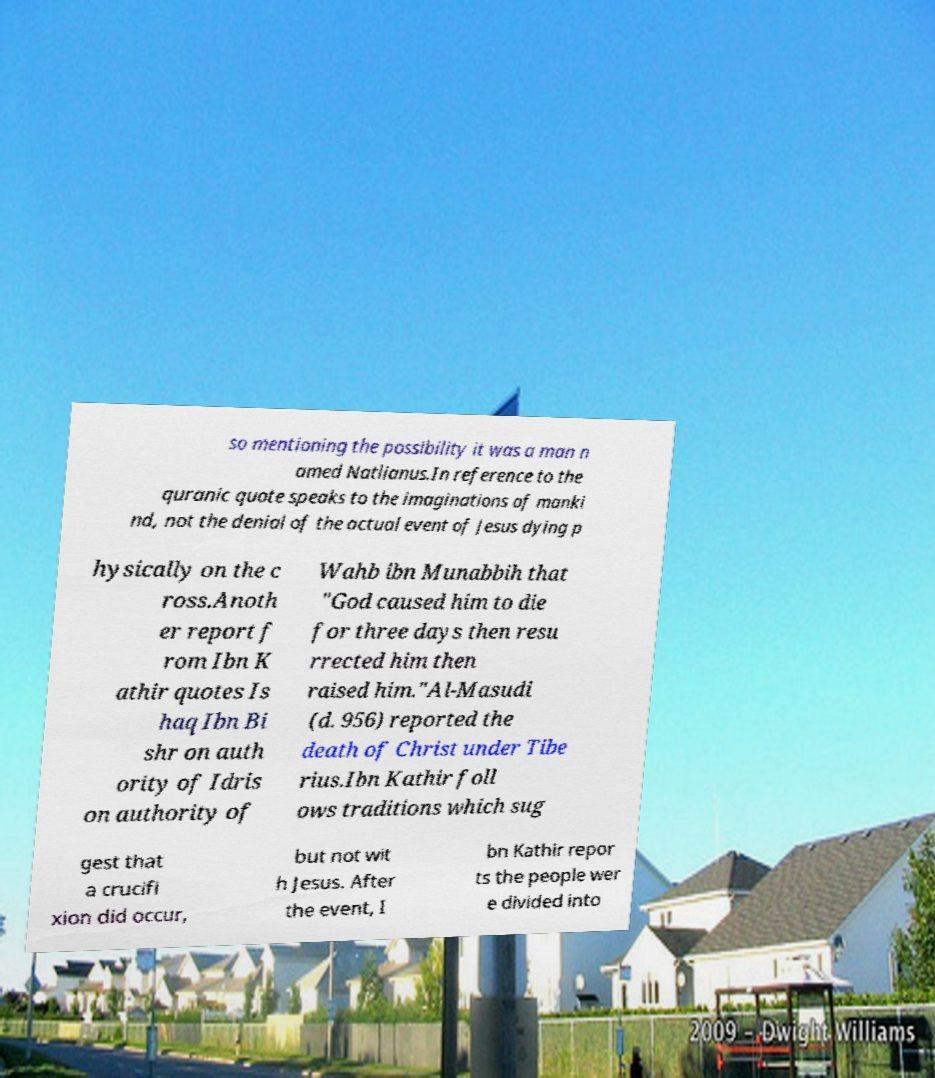Can you accurately transcribe the text from the provided image for me? so mentioning the possibility it was a man n amed Natlianus.In reference to the quranic quote speaks to the imaginations of manki nd, not the denial of the actual event of Jesus dying p hysically on the c ross.Anoth er report f rom Ibn K athir quotes Is haq Ibn Bi shr on auth ority of Idris on authority of Wahb ibn Munabbih that "God caused him to die for three days then resu rrected him then raised him."Al-Masudi (d. 956) reported the death of Christ under Tibe rius.Ibn Kathir foll ows traditions which sug gest that a crucifi xion did occur, but not wit h Jesus. After the event, I bn Kathir repor ts the people wer e divided into 